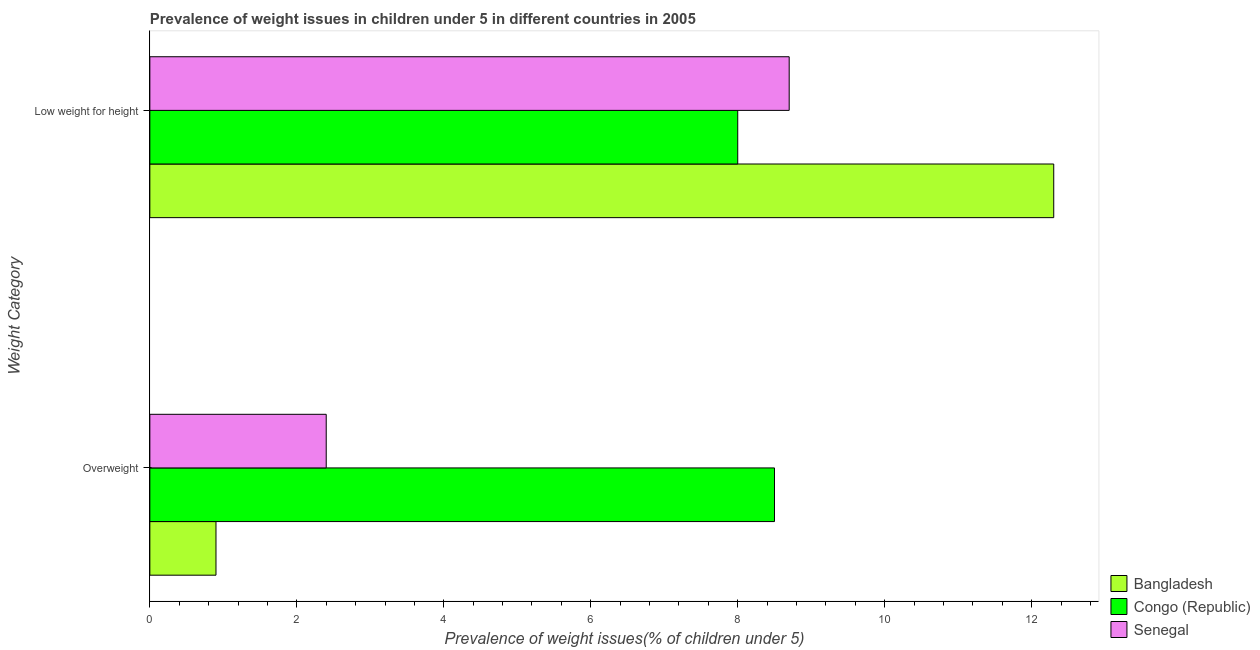How many different coloured bars are there?
Make the answer very short. 3. How many bars are there on the 1st tick from the top?
Your answer should be compact. 3. What is the label of the 2nd group of bars from the top?
Keep it short and to the point. Overweight. In which country was the percentage of overweight children maximum?
Offer a very short reply. Congo (Republic). In which country was the percentage of underweight children minimum?
Your answer should be very brief. Congo (Republic). What is the total percentage of underweight children in the graph?
Keep it short and to the point. 29. What is the difference between the percentage of underweight children in Bangladesh and that in Congo (Republic)?
Give a very brief answer. 4.3. What is the difference between the percentage of overweight children in Congo (Republic) and the percentage of underweight children in Senegal?
Ensure brevity in your answer.  -0.2. What is the average percentage of overweight children per country?
Provide a short and direct response. 3.93. In how many countries, is the percentage of underweight children greater than 7.6 %?
Keep it short and to the point. 3. What is the ratio of the percentage of underweight children in Congo (Republic) to that in Bangladesh?
Your answer should be very brief. 0.65. Is the percentage of underweight children in Bangladesh less than that in Congo (Republic)?
Provide a succinct answer. No. In how many countries, is the percentage of overweight children greater than the average percentage of overweight children taken over all countries?
Give a very brief answer. 1. What does the 1st bar from the top in Overweight represents?
Provide a succinct answer. Senegal. What does the 1st bar from the bottom in Low weight for height represents?
Provide a succinct answer. Bangladesh. How many bars are there?
Provide a short and direct response. 6. Are all the bars in the graph horizontal?
Your response must be concise. Yes. How many countries are there in the graph?
Offer a terse response. 3. Does the graph contain any zero values?
Give a very brief answer. No. What is the title of the graph?
Provide a succinct answer. Prevalence of weight issues in children under 5 in different countries in 2005. What is the label or title of the X-axis?
Your answer should be compact. Prevalence of weight issues(% of children under 5). What is the label or title of the Y-axis?
Your answer should be very brief. Weight Category. What is the Prevalence of weight issues(% of children under 5) of Bangladesh in Overweight?
Your answer should be very brief. 0.9. What is the Prevalence of weight issues(% of children under 5) in Congo (Republic) in Overweight?
Ensure brevity in your answer.  8.5. What is the Prevalence of weight issues(% of children under 5) in Senegal in Overweight?
Provide a short and direct response. 2.4. What is the Prevalence of weight issues(% of children under 5) of Bangladesh in Low weight for height?
Your response must be concise. 12.3. What is the Prevalence of weight issues(% of children under 5) of Senegal in Low weight for height?
Provide a succinct answer. 8.7. Across all Weight Category, what is the maximum Prevalence of weight issues(% of children under 5) in Bangladesh?
Provide a succinct answer. 12.3. Across all Weight Category, what is the maximum Prevalence of weight issues(% of children under 5) of Congo (Republic)?
Your answer should be compact. 8.5. Across all Weight Category, what is the maximum Prevalence of weight issues(% of children under 5) of Senegal?
Provide a short and direct response. 8.7. Across all Weight Category, what is the minimum Prevalence of weight issues(% of children under 5) in Bangladesh?
Offer a very short reply. 0.9. Across all Weight Category, what is the minimum Prevalence of weight issues(% of children under 5) of Congo (Republic)?
Your response must be concise. 8. Across all Weight Category, what is the minimum Prevalence of weight issues(% of children under 5) of Senegal?
Your answer should be compact. 2.4. What is the total Prevalence of weight issues(% of children under 5) in Senegal in the graph?
Offer a very short reply. 11.1. What is the difference between the Prevalence of weight issues(% of children under 5) in Congo (Republic) in Overweight and that in Low weight for height?
Make the answer very short. 0.5. What is the difference between the Prevalence of weight issues(% of children under 5) of Bangladesh in Overweight and the Prevalence of weight issues(% of children under 5) of Congo (Republic) in Low weight for height?
Offer a very short reply. -7.1. What is the difference between the Prevalence of weight issues(% of children under 5) in Bangladesh in Overweight and the Prevalence of weight issues(% of children under 5) in Senegal in Low weight for height?
Keep it short and to the point. -7.8. What is the average Prevalence of weight issues(% of children under 5) in Bangladesh per Weight Category?
Your answer should be compact. 6.6. What is the average Prevalence of weight issues(% of children under 5) in Congo (Republic) per Weight Category?
Provide a succinct answer. 8.25. What is the average Prevalence of weight issues(% of children under 5) in Senegal per Weight Category?
Keep it short and to the point. 5.55. What is the difference between the Prevalence of weight issues(% of children under 5) of Bangladesh and Prevalence of weight issues(% of children under 5) of Congo (Republic) in Overweight?
Your response must be concise. -7.6. What is the difference between the Prevalence of weight issues(% of children under 5) in Bangladesh and Prevalence of weight issues(% of children under 5) in Senegal in Overweight?
Your response must be concise. -1.5. What is the difference between the Prevalence of weight issues(% of children under 5) of Bangladesh and Prevalence of weight issues(% of children under 5) of Congo (Republic) in Low weight for height?
Offer a very short reply. 4.3. What is the difference between the Prevalence of weight issues(% of children under 5) of Bangladesh and Prevalence of weight issues(% of children under 5) of Senegal in Low weight for height?
Your answer should be compact. 3.6. What is the ratio of the Prevalence of weight issues(% of children under 5) of Bangladesh in Overweight to that in Low weight for height?
Keep it short and to the point. 0.07. What is the ratio of the Prevalence of weight issues(% of children under 5) of Congo (Republic) in Overweight to that in Low weight for height?
Provide a short and direct response. 1.06. What is the ratio of the Prevalence of weight issues(% of children under 5) in Senegal in Overweight to that in Low weight for height?
Your answer should be very brief. 0.28. What is the difference between the highest and the second highest Prevalence of weight issues(% of children under 5) of Bangladesh?
Ensure brevity in your answer.  11.4. What is the difference between the highest and the second highest Prevalence of weight issues(% of children under 5) in Senegal?
Keep it short and to the point. 6.3. What is the difference between the highest and the lowest Prevalence of weight issues(% of children under 5) in Congo (Republic)?
Offer a very short reply. 0.5. What is the difference between the highest and the lowest Prevalence of weight issues(% of children under 5) of Senegal?
Offer a very short reply. 6.3. 